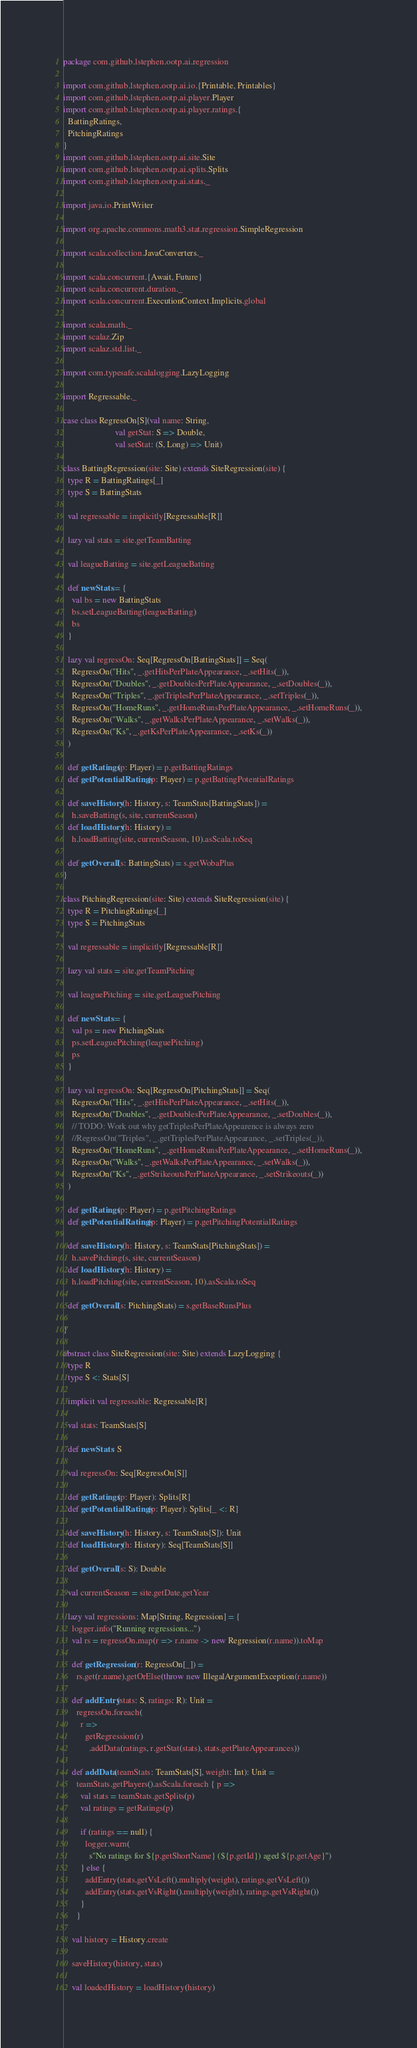<code> <loc_0><loc_0><loc_500><loc_500><_Scala_>package com.github.lstephen.ootp.ai.regression

import com.github.lstephen.ootp.ai.io.{Printable, Printables}
import com.github.lstephen.ootp.ai.player.Player
import com.github.lstephen.ootp.ai.player.ratings.{
  BattingRatings,
  PitchingRatings
}
import com.github.lstephen.ootp.ai.site.Site
import com.github.lstephen.ootp.ai.splits.Splits
import com.github.lstephen.ootp.ai.stats._

import java.io.PrintWriter

import org.apache.commons.math3.stat.regression.SimpleRegression

import scala.collection.JavaConverters._

import scala.concurrent.{Await, Future}
import scala.concurrent.duration._
import scala.concurrent.ExecutionContext.Implicits.global

import scala.math._
import scalaz.Zip
import scalaz.std.list._

import com.typesafe.scalalogging.LazyLogging

import Regressable._

case class RegressOn[S](val name: String,
                        val getStat: S => Double,
                        val setStat: (S, Long) => Unit)

class BattingRegression(site: Site) extends SiteRegression(site) {
  type R = BattingRatings[_]
  type S = BattingStats

  val regressable = implicitly[Regressable[R]]

  lazy val stats = site.getTeamBatting

  val leagueBatting = site.getLeagueBatting

  def newStats = {
    val bs = new BattingStats
    bs.setLeagueBatting(leagueBatting)
    bs
  }

  lazy val regressOn: Seq[RegressOn[BattingStats]] = Seq(
    RegressOn("Hits", _.getHitsPerPlateAppearance, _.setHits(_)),
    RegressOn("Doubles", _.getDoublesPerPlateAppearance, _.setDoubles(_)),
    RegressOn("Triples", _.getTriplesPerPlateAppearance, _.setTriples(_)),
    RegressOn("HomeRuns", _.getHomeRunsPerPlateAppearance, _.setHomeRuns(_)),
    RegressOn("Walks", _.getWalksPerPlateAppearance, _.setWalks(_)),
    RegressOn("Ks", _.getKsPerPlateAppearance, _.setKs(_))
  )

  def getRatings(p: Player) = p.getBattingRatings
  def getPotentialRatings(p: Player) = p.getBattingPotentialRatings

  def saveHistory(h: History, s: TeamStats[BattingStats]) =
    h.saveBatting(s, site, currentSeason)
  def loadHistory(h: History) =
    h.loadBatting(site, currentSeason, 10).asScala.toSeq

  def getOverall(s: BattingStats) = s.getWobaPlus
}

class PitchingRegression(site: Site) extends SiteRegression(site) {
  type R = PitchingRatings[_]
  type S = PitchingStats

  val regressable = implicitly[Regressable[R]]

  lazy val stats = site.getTeamPitching

  val leaguePitching = site.getLeaguePitching

  def newStats = {
    val ps = new PitchingStats
    ps.setLeaguePitching(leaguePitching)
    ps
  }

  lazy val regressOn: Seq[RegressOn[PitchingStats]] = Seq(
    RegressOn("Hits", _.getHitsPerPlateAppearance, _.setHits(_)),
    RegressOn("Doubles", _.getDoublesPerPlateAppearance, _.setDoubles(_)),
    // TODO: Work out why getTriplesPerPlateAppearence is always zero
    //RegressOn("Triples", _.getTriplesPerPlateAppearance, _.setTriples(_)),
    RegressOn("HomeRuns", _.getHomeRunsPerPlateAppearance, _.setHomeRuns(_)),
    RegressOn("Walks", _.getWalksPerPlateAppearance, _.setWalks(_)),
    RegressOn("Ks", _.getStrikeoutsPerPlateAppearance, _.setStrikeouts(_))
  )

  def getRatings(p: Player) = p.getPitchingRatings
  def getPotentialRatings(p: Player) = p.getPitchingPotentialRatings

  def saveHistory(h: History, s: TeamStats[PitchingStats]) =
    h.savePitching(s, site, currentSeason)
  def loadHistory(h: History) =
    h.loadPitching(site, currentSeason, 10).asScala.toSeq

  def getOverall(s: PitchingStats) = s.getBaseRunsPlus

}

abstract class SiteRegression(site: Site) extends LazyLogging {
  type R
  type S <: Stats[S]

  implicit val regressable: Regressable[R]

  val stats: TeamStats[S]

  def newStats: S

  val regressOn: Seq[RegressOn[S]]

  def getRatings(p: Player): Splits[R]
  def getPotentialRatings(p: Player): Splits[_ <: R]

  def saveHistory(h: History, s: TeamStats[S]): Unit
  def loadHistory(h: History): Seq[TeamStats[S]]

  def getOverall(s: S): Double

  val currentSeason = site.getDate.getYear

  lazy val regressions: Map[String, Regression] = {
    logger.info("Running regressions...")
    val rs = regressOn.map(r => r.name -> new Regression(r.name)).toMap

    def getRegression(r: RegressOn[_]) =
      rs.get(r.name).getOrElse(throw new IllegalArgumentException(r.name))

    def addEntry(stats: S, ratings: R): Unit =
      regressOn.foreach(
        r =>
          getRegression(r)
            .addData(ratings, r.getStat(stats), stats.getPlateAppearances))

    def addData(teamStats: TeamStats[S], weight: Int): Unit =
      teamStats.getPlayers().asScala.foreach { p =>
        val stats = teamStats.getSplits(p)
        val ratings = getRatings(p)

        if (ratings == null) {
          logger.warn(
            s"No ratings for ${p.getShortName} (${p.getId}) aged ${p.getAge}")
        } else {
          addEntry(stats.getVsLeft().multiply(weight), ratings.getVsLeft())
          addEntry(stats.getVsRight().multiply(weight), ratings.getVsRight())
        }
      }

    val history = History.create

    saveHistory(history, stats)

    val loadedHistory = loadHistory(history)
</code> 